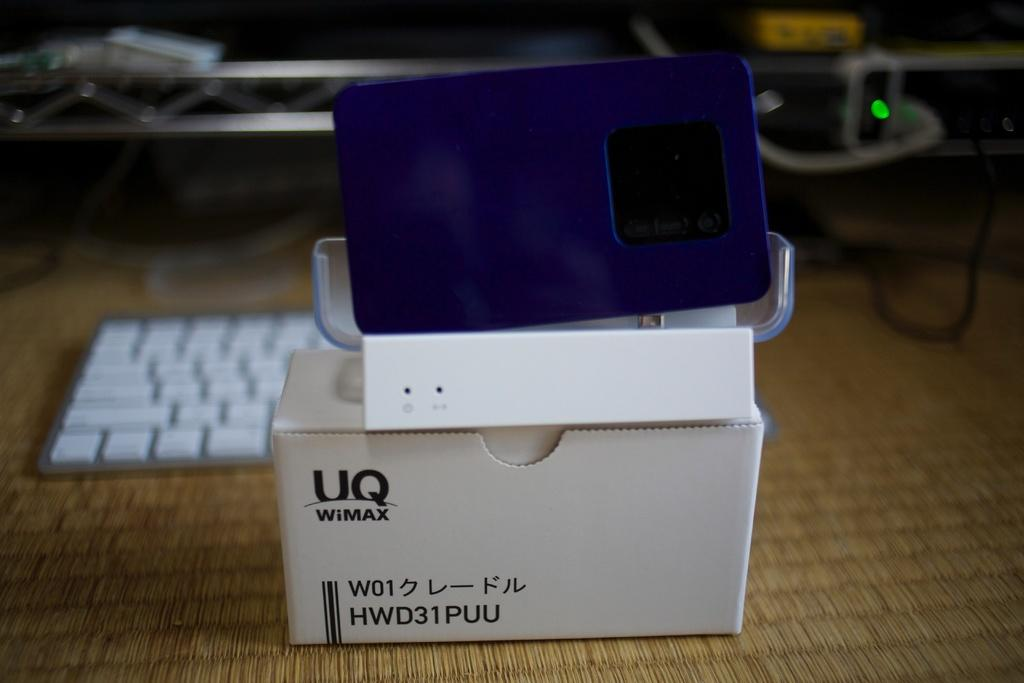<image>
Create a compact narrative representing the image presented. a white box with a device from UQ WiMAX 